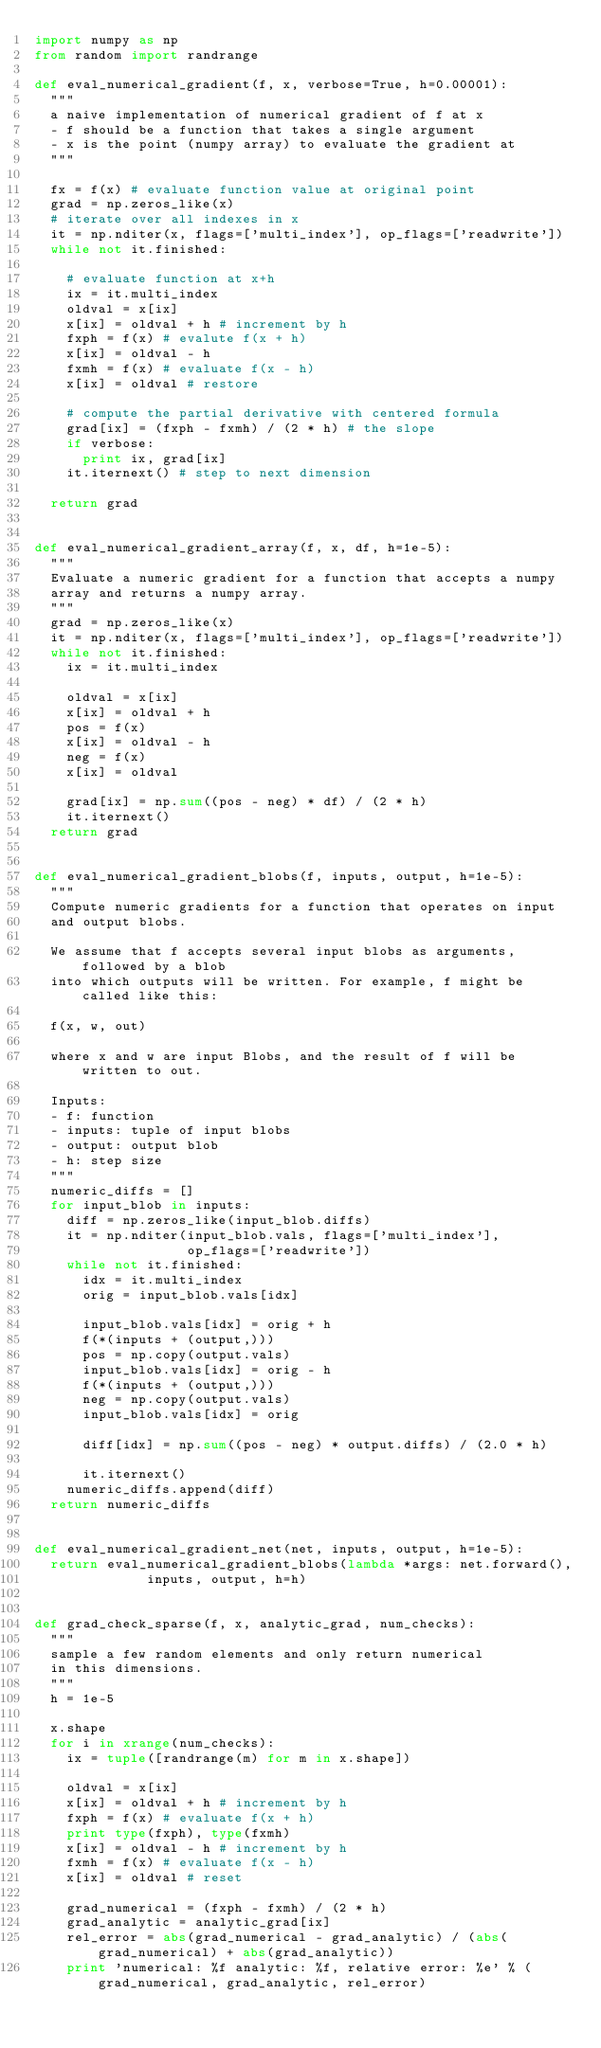Convert code to text. <code><loc_0><loc_0><loc_500><loc_500><_Python_>import numpy as np
from random import randrange

def eval_numerical_gradient(f, x, verbose=True, h=0.00001):
  """ 
  a naive implementation of numerical gradient of f at x 
  - f should be a function that takes a single argument
  - x is the point (numpy array) to evaluate the gradient at
  """ 

  fx = f(x) # evaluate function value at original point
  grad = np.zeros_like(x)
  # iterate over all indexes in x
  it = np.nditer(x, flags=['multi_index'], op_flags=['readwrite'])
  while not it.finished:

    # evaluate function at x+h
    ix = it.multi_index
    oldval = x[ix]
    x[ix] = oldval + h # increment by h
    fxph = f(x) # evalute f(x + h)
    x[ix] = oldval - h
    fxmh = f(x) # evaluate f(x - h)
    x[ix] = oldval # restore

    # compute the partial derivative with centered formula
    grad[ix] = (fxph - fxmh) / (2 * h) # the slope
    if verbose:
      print ix, grad[ix]
    it.iternext() # step to next dimension

  return grad


def eval_numerical_gradient_array(f, x, df, h=1e-5):
  """
  Evaluate a numeric gradient for a function that accepts a numpy
  array and returns a numpy array.
  """
  grad = np.zeros_like(x)
  it = np.nditer(x, flags=['multi_index'], op_flags=['readwrite'])
  while not it.finished:
    ix = it.multi_index
    
    oldval = x[ix]
    x[ix] = oldval + h
    pos = f(x)
    x[ix] = oldval - h
    neg = f(x)
    x[ix] = oldval
    
    grad[ix] = np.sum((pos - neg) * df) / (2 * h)
    it.iternext()
  return grad


def eval_numerical_gradient_blobs(f, inputs, output, h=1e-5):
  """
  Compute numeric gradients for a function that operates on input
  and output blobs.
  
  We assume that f accepts several input blobs as arguments, followed by a blob
  into which outputs will be written. For example, f might be called like this:

  f(x, w, out)
  
  where x and w are input Blobs, and the result of f will be written to out.

  Inputs: 
  - f: function
  - inputs: tuple of input blobs
  - output: output blob
  - h: step size
  """
  numeric_diffs = []
  for input_blob in inputs:
    diff = np.zeros_like(input_blob.diffs)
    it = np.nditer(input_blob.vals, flags=['multi_index'],
                   op_flags=['readwrite'])
    while not it.finished:
      idx = it.multi_index
      orig = input_blob.vals[idx]

      input_blob.vals[idx] = orig + h
      f(*(inputs + (output,)))
      pos = np.copy(output.vals)
      input_blob.vals[idx] = orig - h
      f(*(inputs + (output,)))
      neg = np.copy(output.vals)
      input_blob.vals[idx] = orig
      
      diff[idx] = np.sum((pos - neg) * output.diffs) / (2.0 * h)

      it.iternext()
    numeric_diffs.append(diff)
  return numeric_diffs


def eval_numerical_gradient_net(net, inputs, output, h=1e-5):
  return eval_numerical_gradient_blobs(lambda *args: net.forward(),
              inputs, output, h=h)


def grad_check_sparse(f, x, analytic_grad, num_checks):
  """
  sample a few random elements and only return numerical
  in this dimensions.
  """
  h = 1e-5

  x.shape
  for i in xrange(num_checks):
    ix = tuple([randrange(m) for m in x.shape])

    oldval = x[ix]
    x[ix] = oldval + h # increment by h
    fxph = f(x) # evaluate f(x + h)
    print type(fxph), type(fxmh)
    x[ix] = oldval - h # increment by h
    fxmh = f(x) # evaluate f(x - h)
    x[ix] = oldval # reset

    grad_numerical = (fxph - fxmh) / (2 * h)
    grad_analytic = analytic_grad[ix]
    rel_error = abs(grad_numerical - grad_analytic) / (abs(grad_numerical) + abs(grad_analytic))
    print 'numerical: %f analytic: %f, relative error: %e' % (grad_numerical, grad_analytic, rel_error)

</code> 